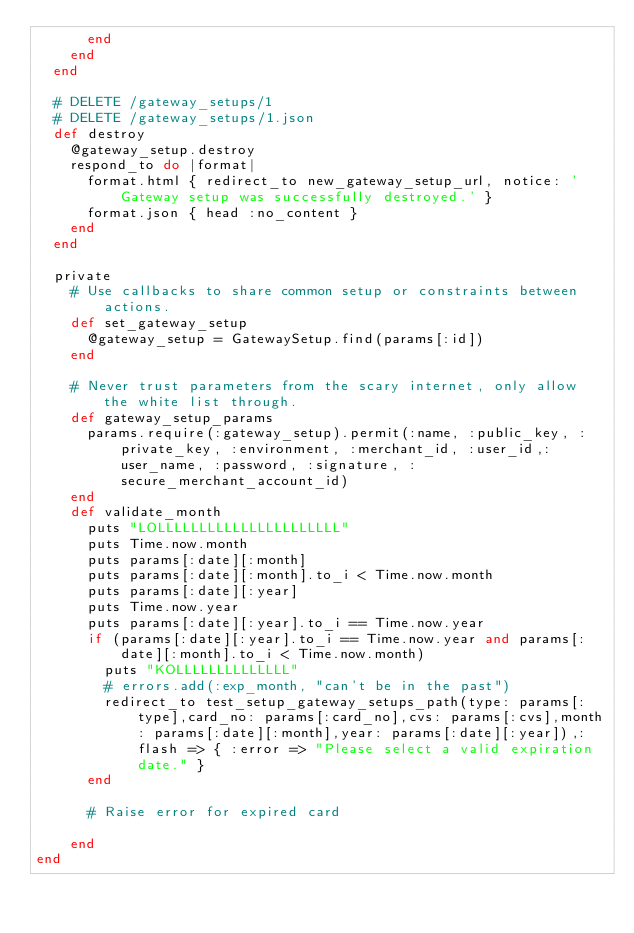<code> <loc_0><loc_0><loc_500><loc_500><_Ruby_>      end
    end
  end

  # DELETE /gateway_setups/1
  # DELETE /gateway_setups/1.json
  def destroy
    @gateway_setup.destroy
    respond_to do |format|
      format.html { redirect_to new_gateway_setup_url, notice: 'Gateway setup was successfully destroyed.' }
      format.json { head :no_content }
    end
  end

  private
    # Use callbacks to share common setup or constraints between actions.
    def set_gateway_setup
      @gateway_setup = GatewaySetup.find(params[:id])
    end

    # Never trust parameters from the scary internet, only allow the white list through.
    def gateway_setup_params
      params.require(:gateway_setup).permit(:name, :public_key, :private_key, :environment, :merchant_id, :user_id,:user_name, :password, :signature, :secure_merchant_account_id)
    end
    def validate_month
      puts "LOLLLLLLLLLLLLLLLLLLLLLL"
      puts Time.now.month
      puts params[:date][:month]
      puts params[:date][:month].to_i < Time.now.month
      puts params[:date][:year]
      puts Time.now.year
      puts params[:date][:year].to_i == Time.now.year
      if (params[:date][:year].to_i == Time.now.year and params[:date][:month].to_i < Time.now.month)
        puts "KOLLLLLLLLLLLLLL"
        # errors.add(:exp_month, "can't be in the past")
        redirect_to test_setup_gateway_setups_path(type: params[:type],card_no: params[:card_no],cvs: params[:cvs],month: params[:date][:month],year: params[:date][:year]),:flash => { :error => "Please select a valid expiration date." }
      end

      # Raise error for expired card
      
    end
end
</code> 